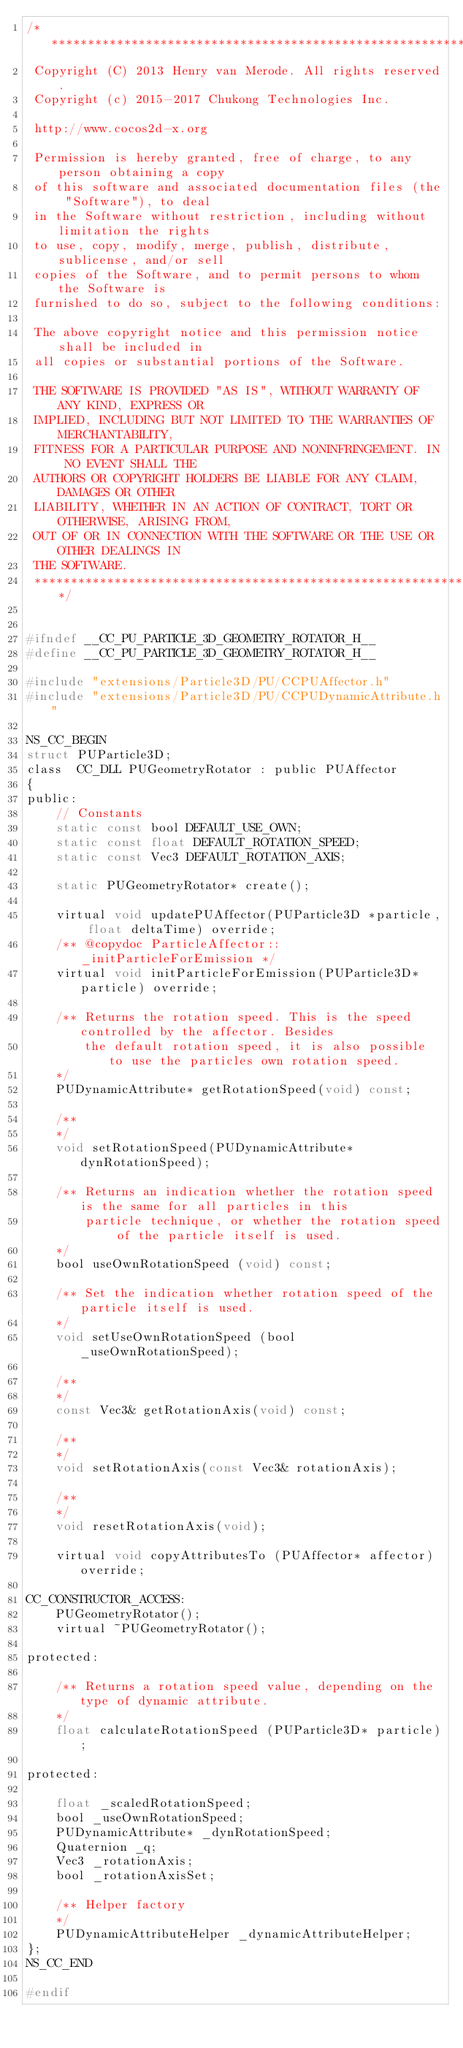Convert code to text. <code><loc_0><loc_0><loc_500><loc_500><_C_>/****************************************************************************
 Copyright (C) 2013 Henry van Merode. All rights reserved.
 Copyright (c) 2015-2017 Chukong Technologies Inc.
 
 http://www.cocos2d-x.org
 
 Permission is hereby granted, free of charge, to any person obtaining a copy
 of this software and associated documentation files (the "Software"), to deal
 in the Software without restriction, including without limitation the rights
 to use, copy, modify, merge, publish, distribute, sublicense, and/or sell
 copies of the Software, and to permit persons to whom the Software is
 furnished to do so, subject to the following conditions:
 
 The above copyright notice and this permission notice shall be included in
 all copies or substantial portions of the Software.
 
 THE SOFTWARE IS PROVIDED "AS IS", WITHOUT WARRANTY OF ANY KIND, EXPRESS OR
 IMPLIED, INCLUDING BUT NOT LIMITED TO THE WARRANTIES OF MERCHANTABILITY,
 FITNESS FOR A PARTICULAR PURPOSE AND NONINFRINGEMENT. IN NO EVENT SHALL THE
 AUTHORS OR COPYRIGHT HOLDERS BE LIABLE FOR ANY CLAIM, DAMAGES OR OTHER
 LIABILITY, WHETHER IN AN ACTION OF CONTRACT, TORT OR OTHERWISE, ARISING FROM,
 OUT OF OR IN CONNECTION WITH THE SOFTWARE OR THE USE OR OTHER DEALINGS IN
 THE SOFTWARE.
 ****************************************************************************/


#ifndef __CC_PU_PARTICLE_3D_GEOMETRY_ROTATOR_H__
#define __CC_PU_PARTICLE_3D_GEOMETRY_ROTATOR_H__

#include "extensions/Particle3D/PU/CCPUAffector.h"
#include "extensions/Particle3D/PU/CCPUDynamicAttribute.h"

NS_CC_BEGIN
struct PUParticle3D;
class  CC_DLL PUGeometryRotator : public PUAffector
{
public:
    // Constants
    static const bool DEFAULT_USE_OWN;
    static const float DEFAULT_ROTATION_SPEED;
    static const Vec3 DEFAULT_ROTATION_AXIS;

    static PUGeometryRotator* create();

    virtual void updatePUAffector(PUParticle3D *particle, float deltaTime) override;
    /** @copydoc ParticleAffector::_initParticleForEmission */
    virtual void initParticleForEmission(PUParticle3D* particle) override;

    /** Returns the rotation speed. This is the speed controlled by the affector. Besides
        the default rotation speed, it is also possible to use the particles own rotation speed.
    */
    PUDynamicAttribute* getRotationSpeed(void) const;

    /** 
    */
    void setRotationSpeed(PUDynamicAttribute* dynRotationSpeed);

    /** Returns an indication whether the rotation speed is the same for all particles in this 
        particle technique, or whether the rotation speed of the particle itself is used.
    */
    bool useOwnRotationSpeed (void) const;

    /** Set the indication whether rotation speed of the particle itself is used.
    */
    void setUseOwnRotationSpeed (bool _useOwnRotationSpeed);

    /** 
    */
    const Vec3& getRotationAxis(void) const;

    /** 
    */
    void setRotationAxis(const Vec3& rotationAxis);

    /** 
    */
    void resetRotationAxis(void);

    virtual void copyAttributesTo (PUAffector* affector) override;

CC_CONSTRUCTOR_ACCESS:
    PUGeometryRotator();
    virtual ~PUGeometryRotator();

protected:

    /** Returns a rotation speed value, depending on the type of dynamic attribute.
    */
    float calculateRotationSpeed (PUParticle3D* particle);

protected:

    float _scaledRotationSpeed;
    bool _useOwnRotationSpeed;
    PUDynamicAttribute* _dynRotationSpeed;
    Quaternion _q;
    Vec3 _rotationAxis;
    bool _rotationAxisSet;

    /** Helper factory
    */
    PUDynamicAttributeHelper _dynamicAttributeHelper;
};
NS_CC_END

#endif</code> 